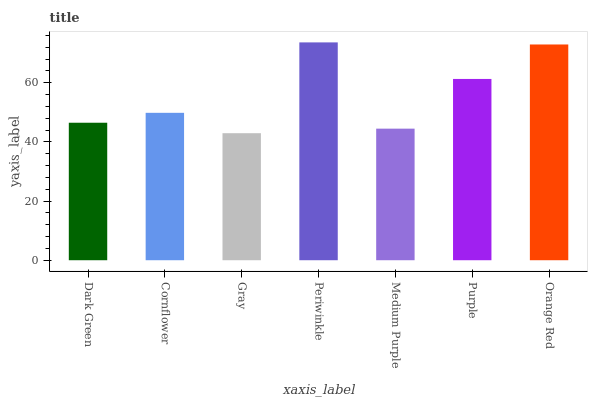Is Gray the minimum?
Answer yes or no. Yes. Is Periwinkle the maximum?
Answer yes or no. Yes. Is Cornflower the minimum?
Answer yes or no. No. Is Cornflower the maximum?
Answer yes or no. No. Is Cornflower greater than Dark Green?
Answer yes or no. Yes. Is Dark Green less than Cornflower?
Answer yes or no. Yes. Is Dark Green greater than Cornflower?
Answer yes or no. No. Is Cornflower less than Dark Green?
Answer yes or no. No. Is Cornflower the high median?
Answer yes or no. Yes. Is Cornflower the low median?
Answer yes or no. Yes. Is Medium Purple the high median?
Answer yes or no. No. Is Dark Green the low median?
Answer yes or no. No. 